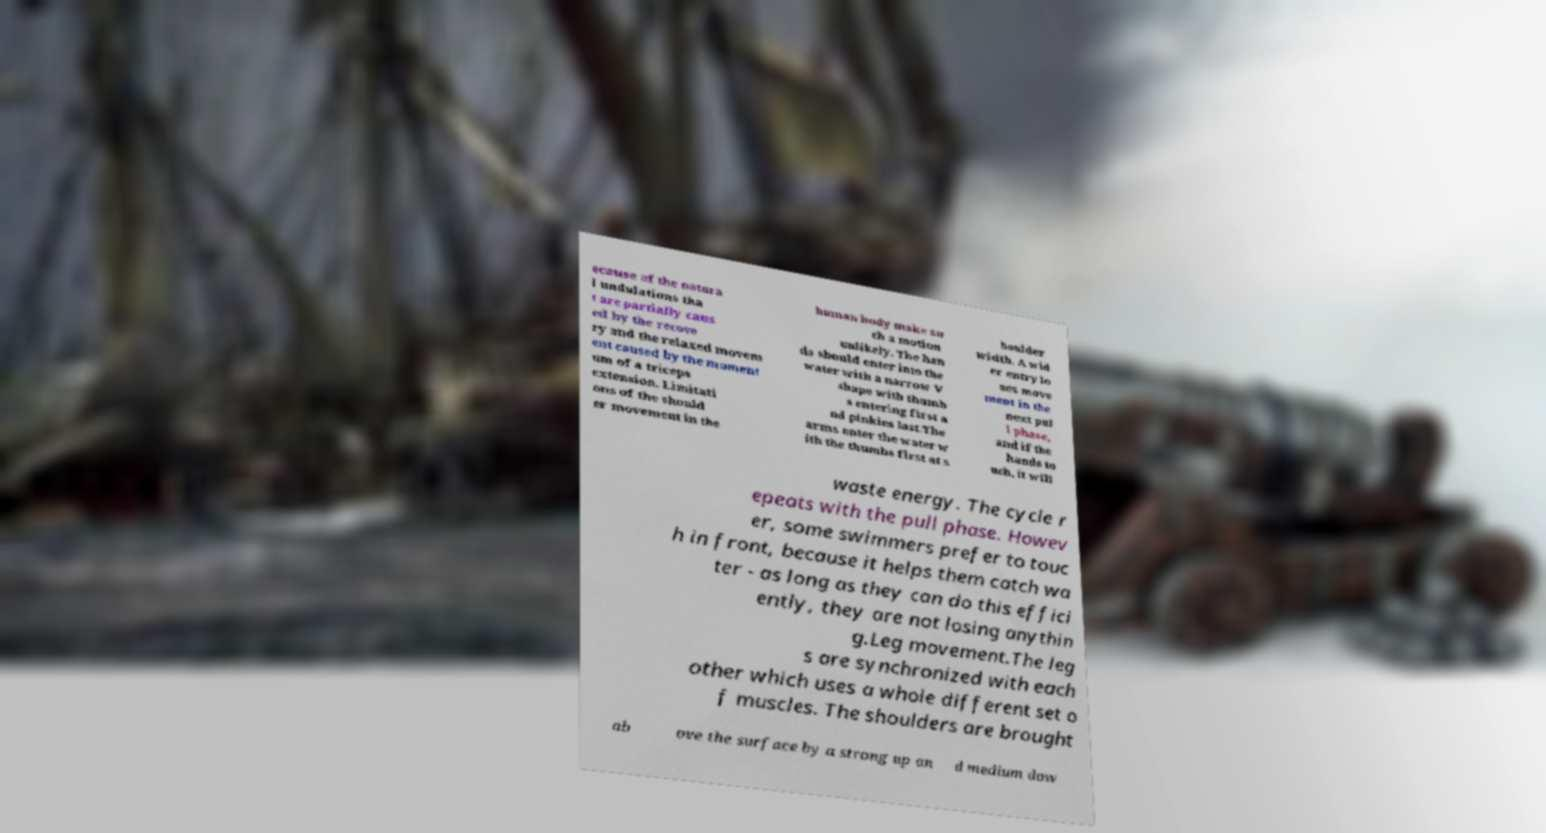There's text embedded in this image that I need extracted. Can you transcribe it verbatim? ecause of the natura l undulations tha t are partially caus ed by the recove ry and the relaxed movem ent caused by the moment um of a triceps extension. Limitati ons of the should er movement in the human body make su ch a motion unlikely. The han ds should enter into the water with a narrow V shape with thumb s entering first a nd pinkies last.The arms enter the water w ith the thumbs first at s houlder width. A wid er entry lo ses move ment in the next pul l phase, and if the hands to uch, it will waste energy. The cycle r epeats with the pull phase. Howev er, some swimmers prefer to touc h in front, because it helps them catch wa ter - as long as they can do this effici ently, they are not losing anythin g.Leg movement.The leg s are synchronized with each other which uses a whole different set o f muscles. The shoulders are brought ab ove the surface by a strong up an d medium dow 